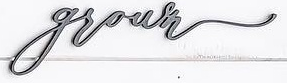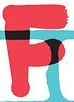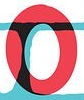What text appears in these images from left to right, separated by a semicolon? grown; F; O 